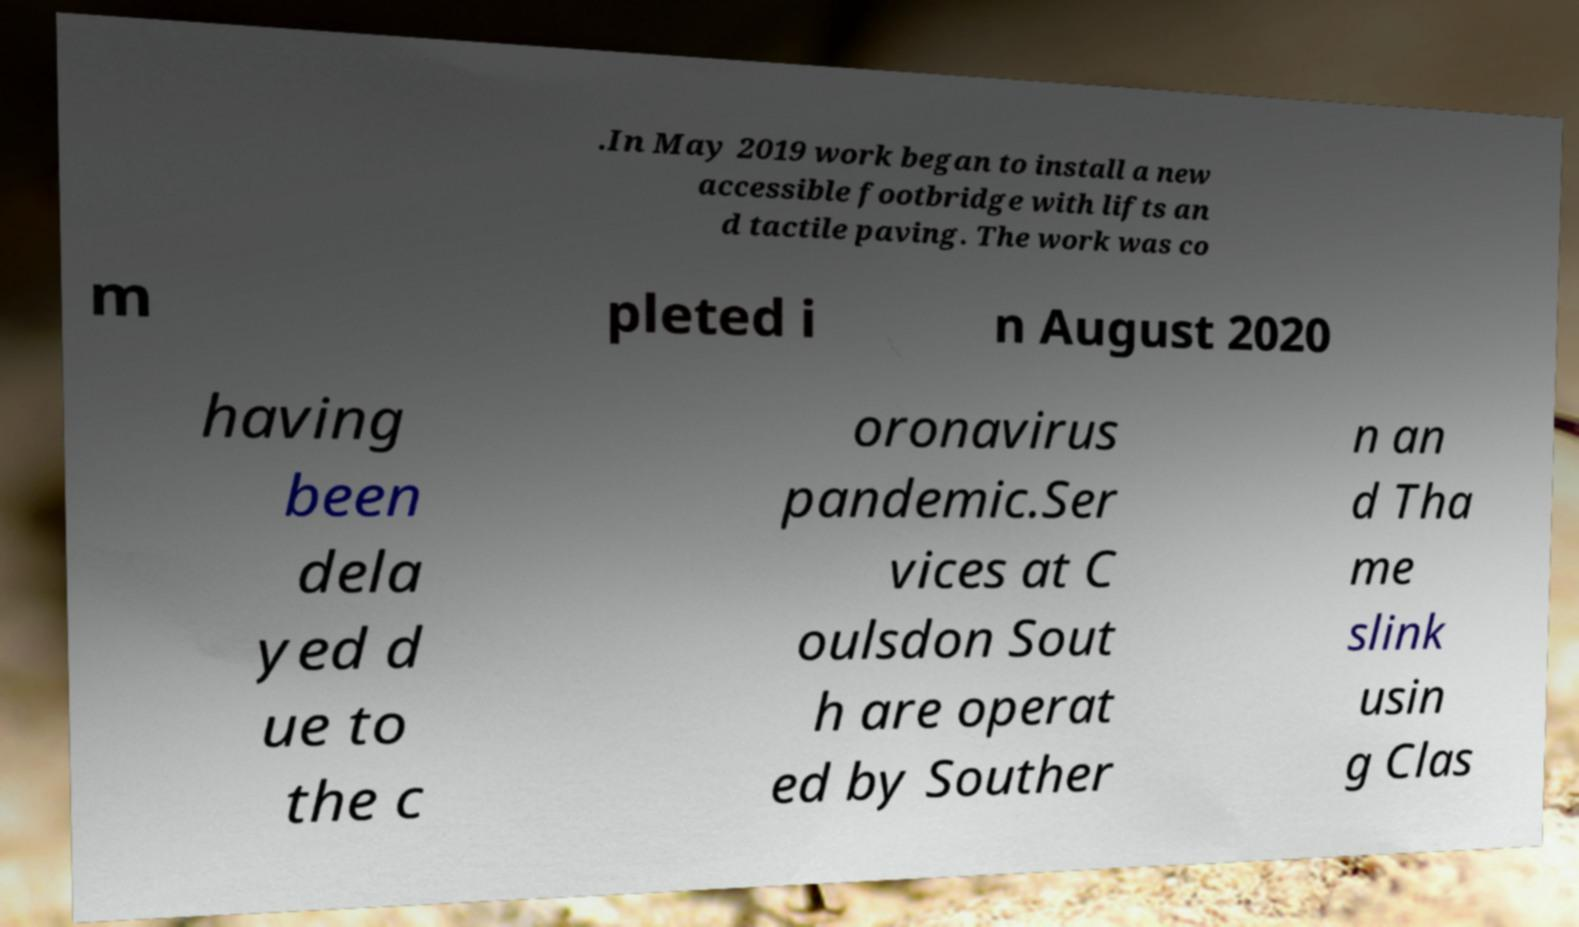What messages or text are displayed in this image? I need them in a readable, typed format. .In May 2019 work began to install a new accessible footbridge with lifts an d tactile paving. The work was co m pleted i n August 2020 having been dela yed d ue to the c oronavirus pandemic.Ser vices at C oulsdon Sout h are operat ed by Souther n an d Tha me slink usin g Clas 